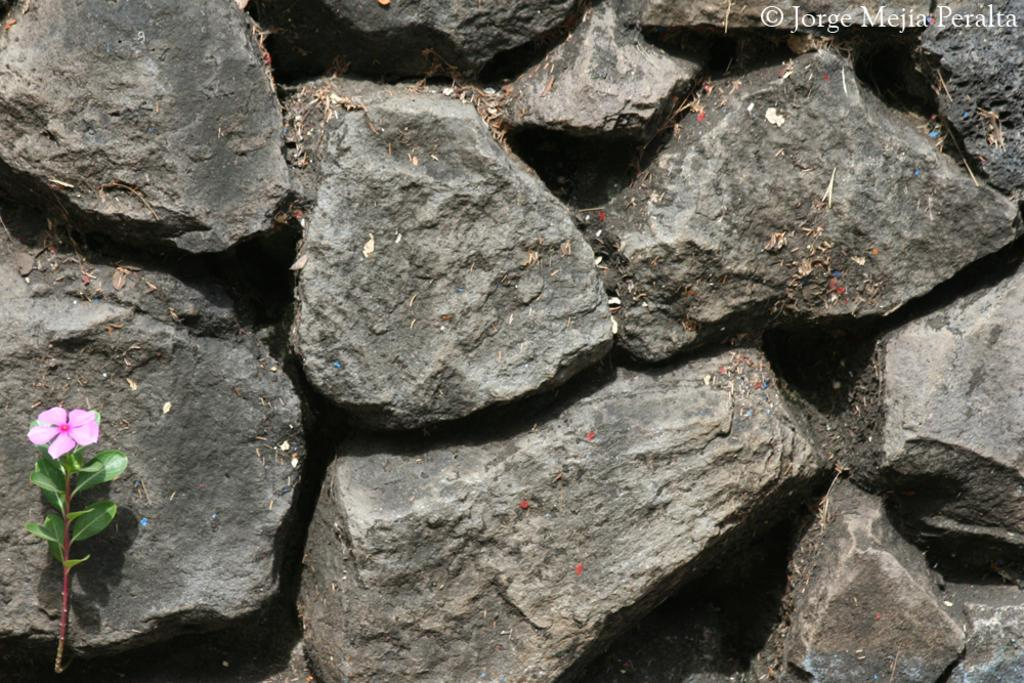What type of flower can be seen in the image? There is a pink flower on a plant in the image. What other objects are present in the image? There are stones in the image. Where is the text located in the image? The text is at the top right of the image. What is the condition of the leaves on the stones in the image? Dried leaves are present on the stones in the image. What type of art can be seen on the bat in the image? There is no bat present in the image, so it is not possible to determine if there is any art on it. 